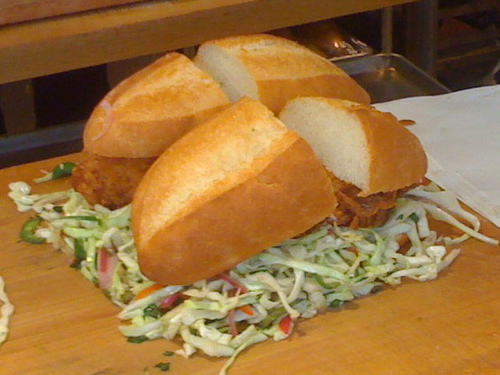What are the ingredients visible in this sandwich? The sandwich contains a fried, breaded protein—possibly chicken or fish—served on a baguette with what appears to be a mayonnaise-based dressing and coleslaw on the side. 